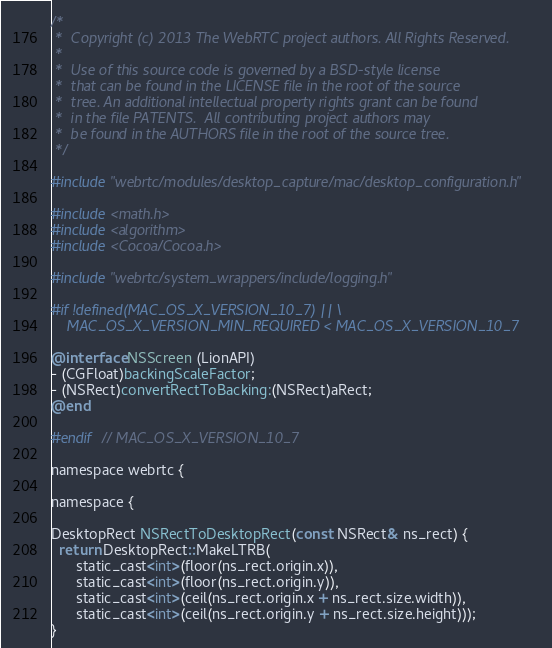Convert code to text. <code><loc_0><loc_0><loc_500><loc_500><_ObjectiveC_>/*
 *  Copyright (c) 2013 The WebRTC project authors. All Rights Reserved.
 *
 *  Use of this source code is governed by a BSD-style license
 *  that can be found in the LICENSE file in the root of the source
 *  tree. An additional intellectual property rights grant can be found
 *  in the file PATENTS.  All contributing project authors may
 *  be found in the AUTHORS file in the root of the source tree.
 */

#include "webrtc/modules/desktop_capture/mac/desktop_configuration.h"

#include <math.h>
#include <algorithm>
#include <Cocoa/Cocoa.h>

#include "webrtc/system_wrappers/include/logging.h"

#if !defined(MAC_OS_X_VERSION_10_7) || \
    MAC_OS_X_VERSION_MIN_REQUIRED < MAC_OS_X_VERSION_10_7

@interface NSScreen (LionAPI)
- (CGFloat)backingScaleFactor;
- (NSRect)convertRectToBacking:(NSRect)aRect;
@end

#endif  // MAC_OS_X_VERSION_10_7

namespace webrtc {

namespace {

DesktopRect NSRectToDesktopRect(const NSRect& ns_rect) {
  return DesktopRect::MakeLTRB(
      static_cast<int>(floor(ns_rect.origin.x)),
      static_cast<int>(floor(ns_rect.origin.y)),
      static_cast<int>(ceil(ns_rect.origin.x + ns_rect.size.width)),
      static_cast<int>(ceil(ns_rect.origin.y + ns_rect.size.height)));
}
</code> 